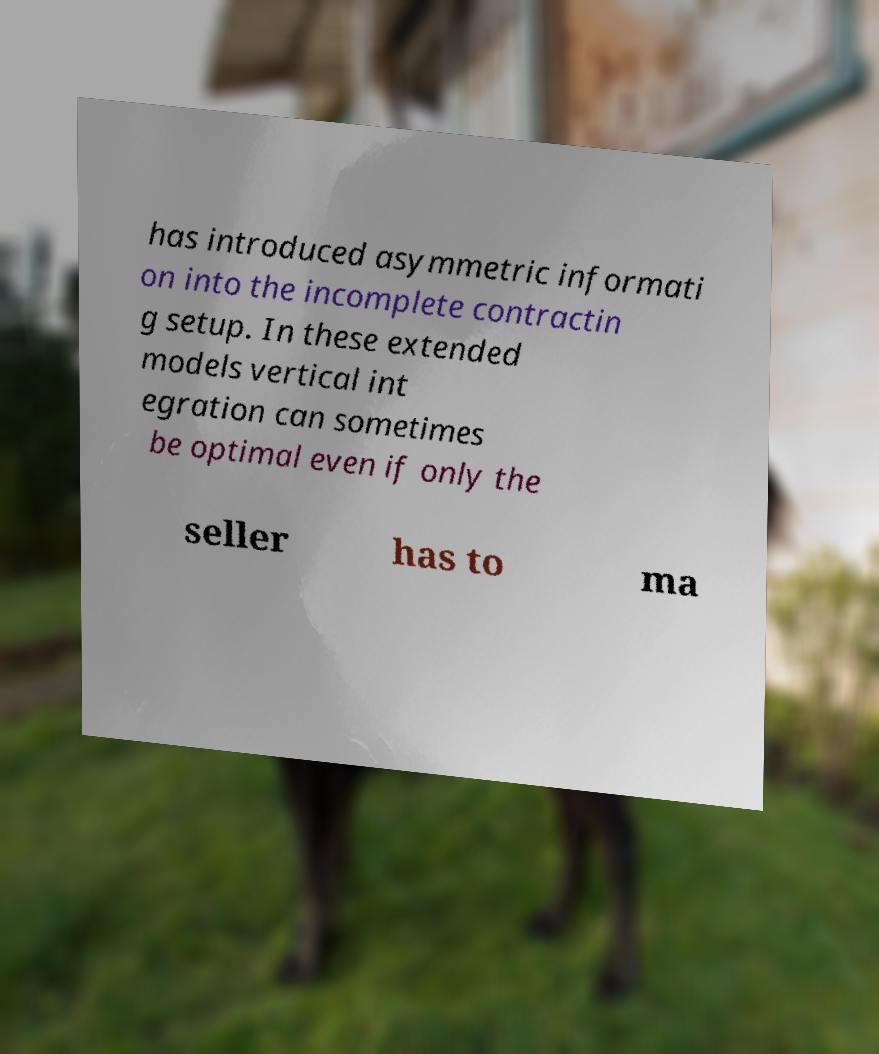For documentation purposes, I need the text within this image transcribed. Could you provide that? has introduced asymmetric informati on into the incomplete contractin g setup. In these extended models vertical int egration can sometimes be optimal even if only the seller has to ma 